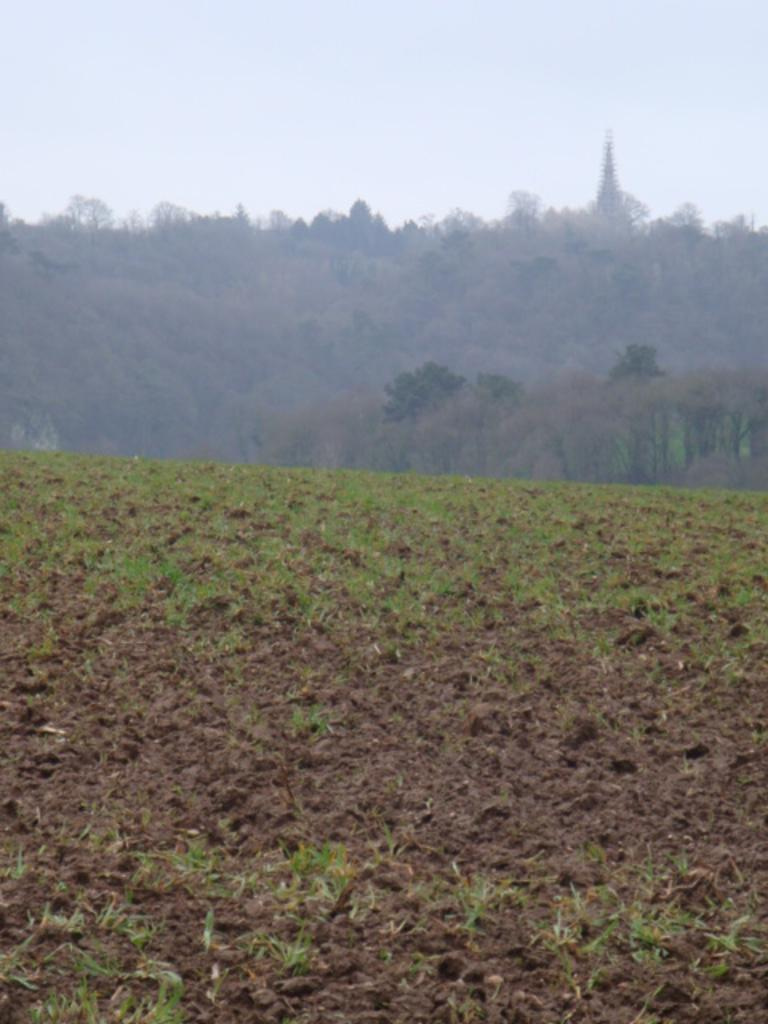What type of terrain is located at the bottom of the image? There is land and sand at the bottom of the image. What can be seen in the middle of the image? There are trees in the middle of the image. What is visible at the top of the image? The sky is visible at the top of the image. What type of vegetation is present on the land? Small grass is present on the land. Can you tell me how many kitties are playing with a paper in the image? There are no kitties or paper present in the image. Is the scene in the image particularly quiet? The provided facts do not mention the level of noise or quietness in the image, so it cannot be determined from the information given. 